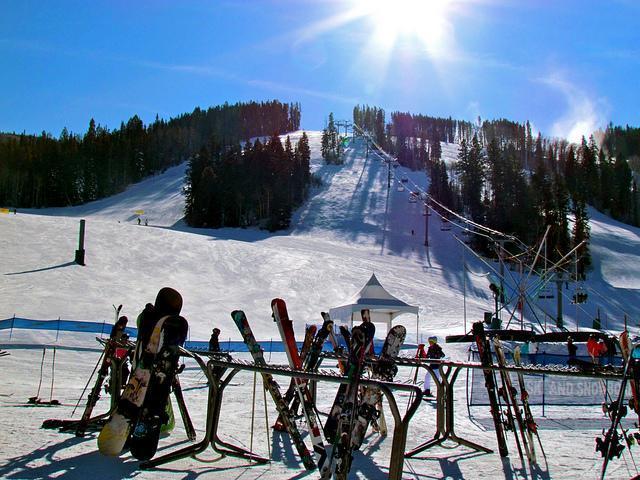How many snowboards can be seen?
Give a very brief answer. 3. How many ski are in the photo?
Give a very brief answer. 3. 